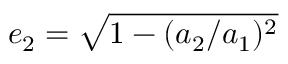<formula> <loc_0><loc_0><loc_500><loc_500>e _ { 2 } = \sqrt { 1 - ( a _ { 2 } / a _ { 1 } ) ^ { 2 } }</formula> 